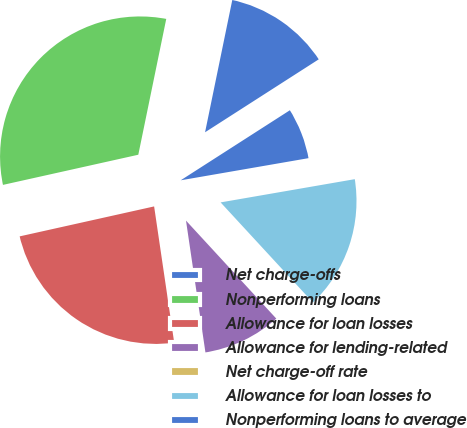Convert chart. <chart><loc_0><loc_0><loc_500><loc_500><pie_chart><fcel>Net charge-offs<fcel>Nonperforming loans<fcel>Allowance for loan losses<fcel>Allowance for lending-related<fcel>Net charge-off rate<fcel>Allowance for loan losses to<fcel>Nonperforming loans to average<nl><fcel>12.69%<fcel>31.72%<fcel>23.84%<fcel>9.52%<fcel>0.01%<fcel>15.87%<fcel>6.35%<nl></chart> 